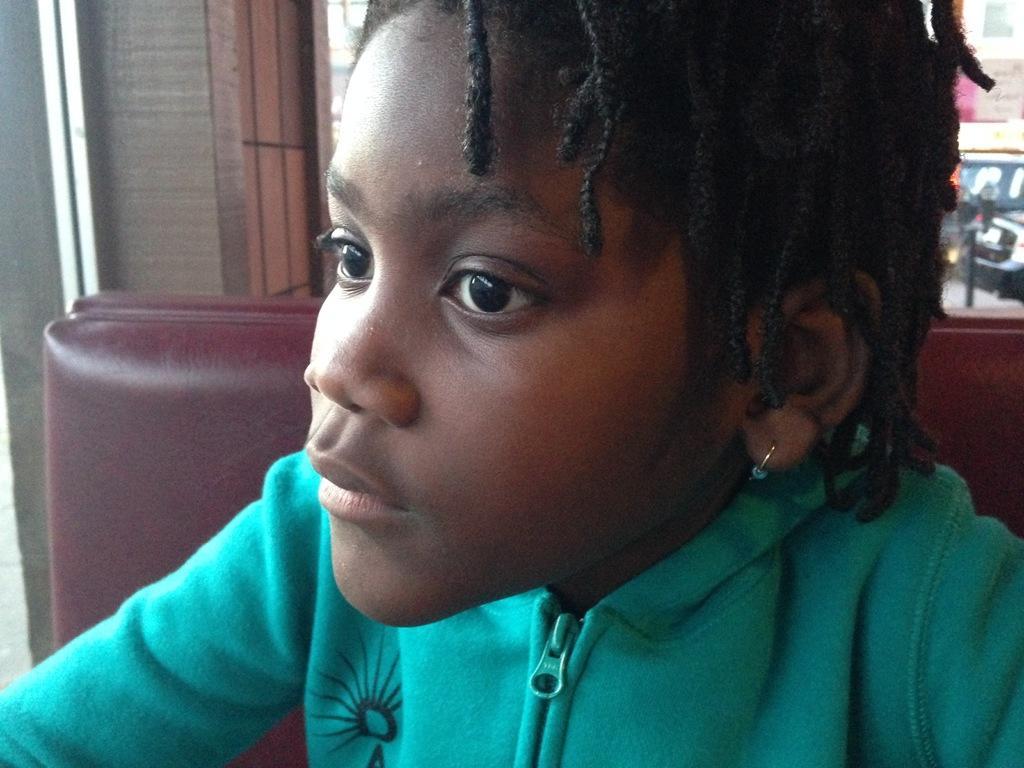Please provide a concise description of this image. In this picture there is a girl with green jacket is sitting on the chair. At the back there are vehicles on the road and there is a building. 